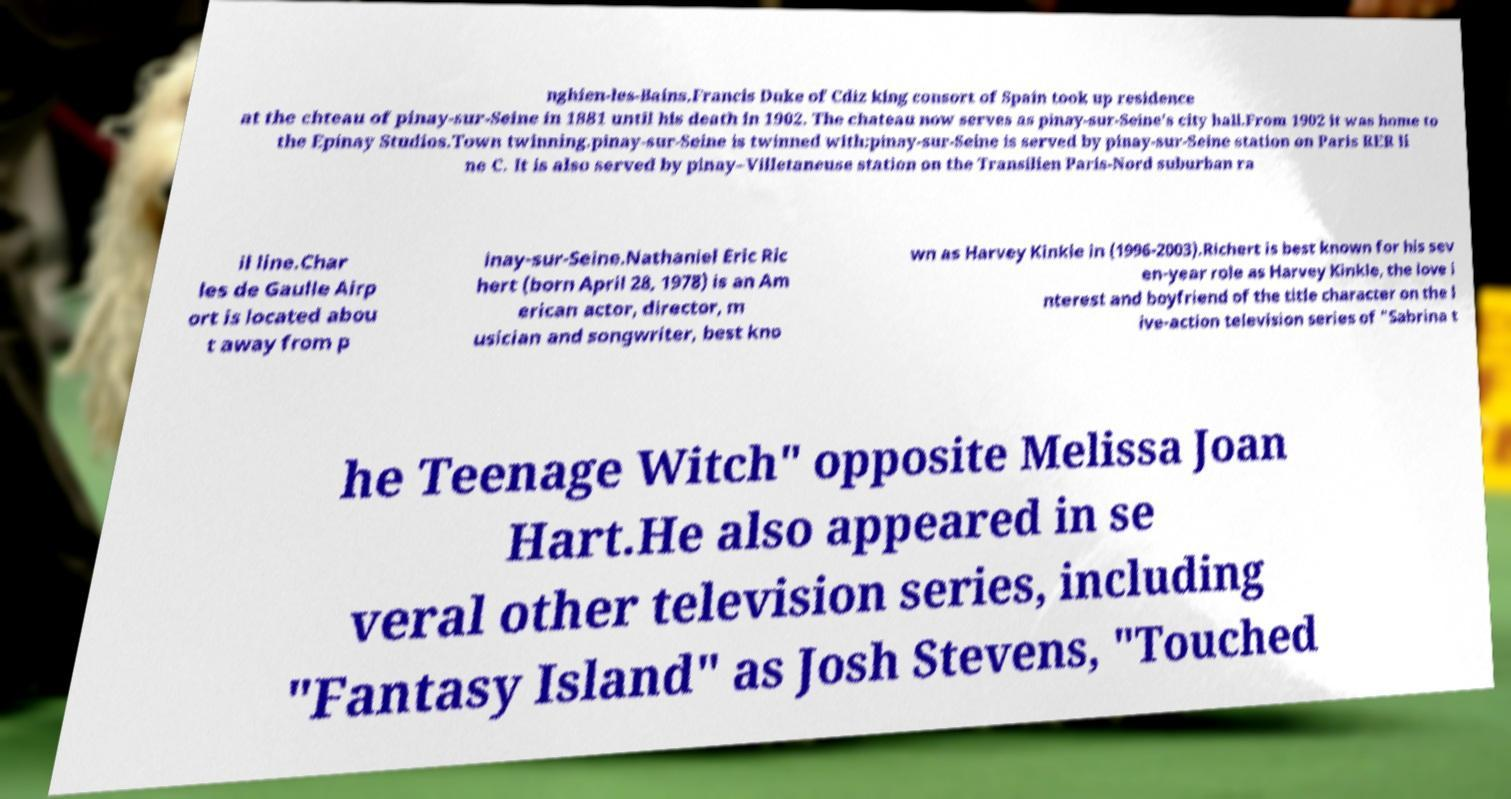There's text embedded in this image that I need extracted. Can you transcribe it verbatim? nghien-les-Bains.Francis Duke of Cdiz king consort of Spain took up residence at the chteau of pinay-sur-Seine in 1881 until his death in 1902. The chateau now serves as pinay-sur-Seine's city hall.From 1902 it was home to the Epinay Studios.Town twinning.pinay-sur-Seine is twinned with:pinay-sur-Seine is served by pinay-sur-Seine station on Paris RER li ne C. It is also served by pinay–Villetaneuse station on the Transilien Paris-Nord suburban ra il line.Char les de Gaulle Airp ort is located abou t away from p inay-sur-Seine.Nathaniel Eric Ric hert (born April 28, 1978) is an Am erican actor, director, m usician and songwriter, best kno wn as Harvey Kinkle in (1996-2003).Richert is best known for his sev en-year role as Harvey Kinkle, the love i nterest and boyfriend of the title character on the l ive-action television series of "Sabrina t he Teenage Witch" opposite Melissa Joan Hart.He also appeared in se veral other television series, including "Fantasy Island" as Josh Stevens, "Touched 